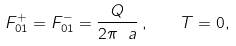<formula> <loc_0><loc_0><loc_500><loc_500>F ^ { + } _ { 0 1 } = F ^ { - } _ { 0 1 } = \frac { Q } { 2 \pi \ a } \, , \quad T = 0 ,</formula> 